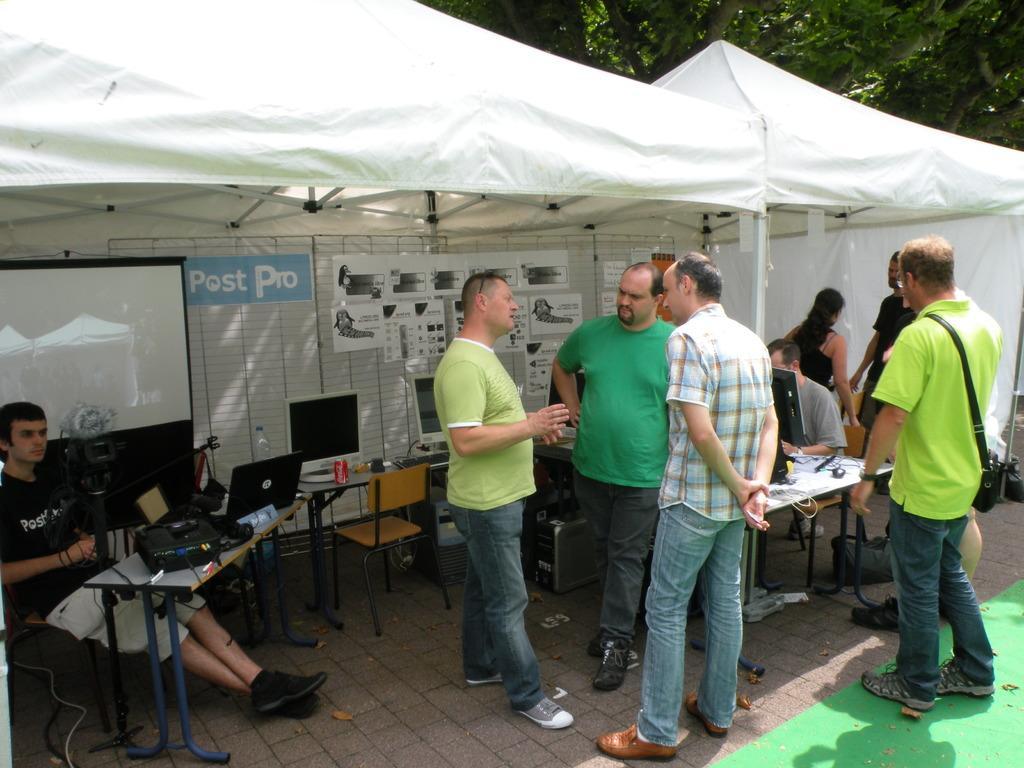Can you describe this image briefly? In the middle of the image there is tent. Behind the text there are some trees. Top left side of the image there is a screen. Bottom left side of the image a man is sitting on a chair. In front of him there is a table on the table there are some laptops and water bottle and tin. Bottom right side of the image few people are standing. 